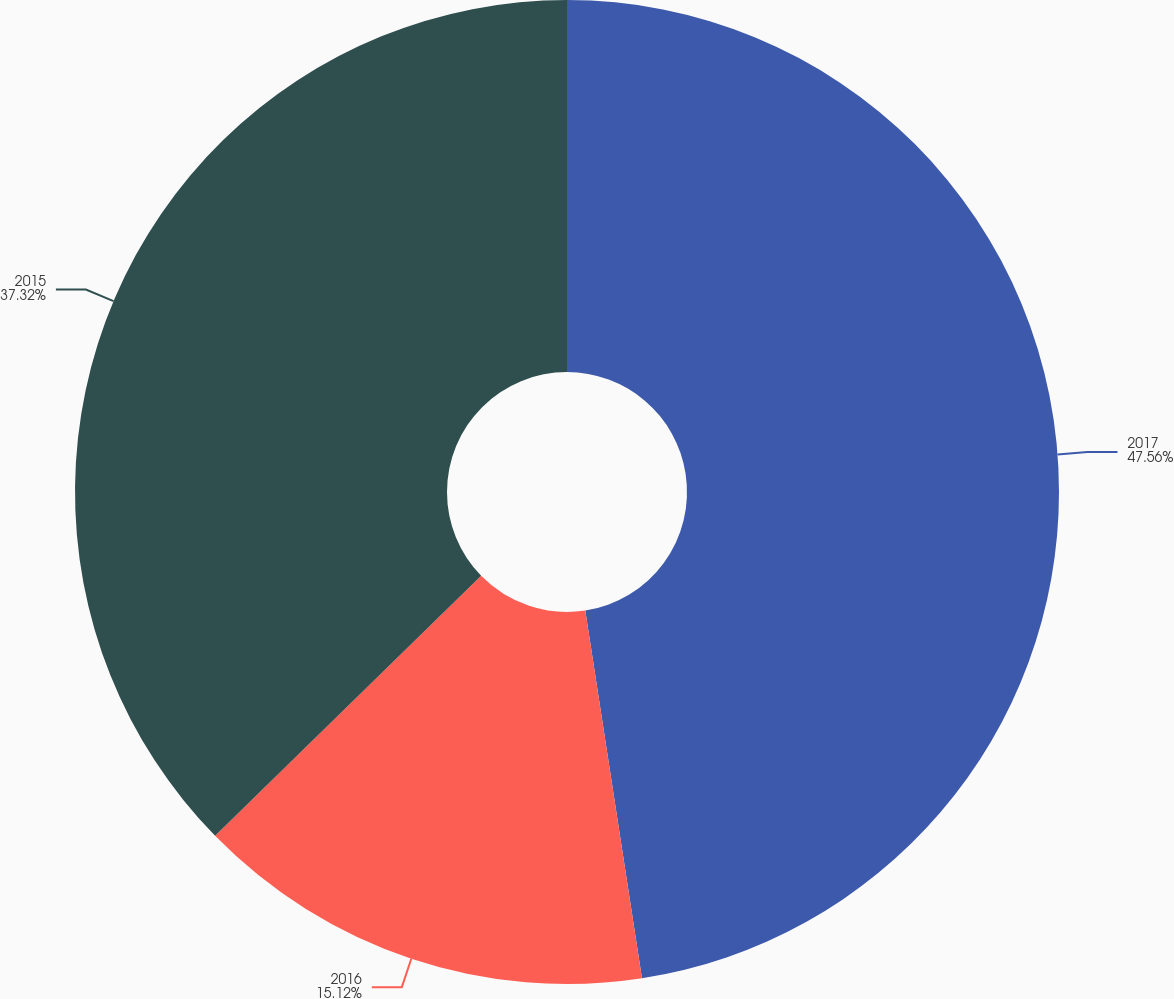<chart> <loc_0><loc_0><loc_500><loc_500><pie_chart><fcel>2017<fcel>2016<fcel>2015<nl><fcel>47.57%<fcel>15.12%<fcel>37.32%<nl></chart> 